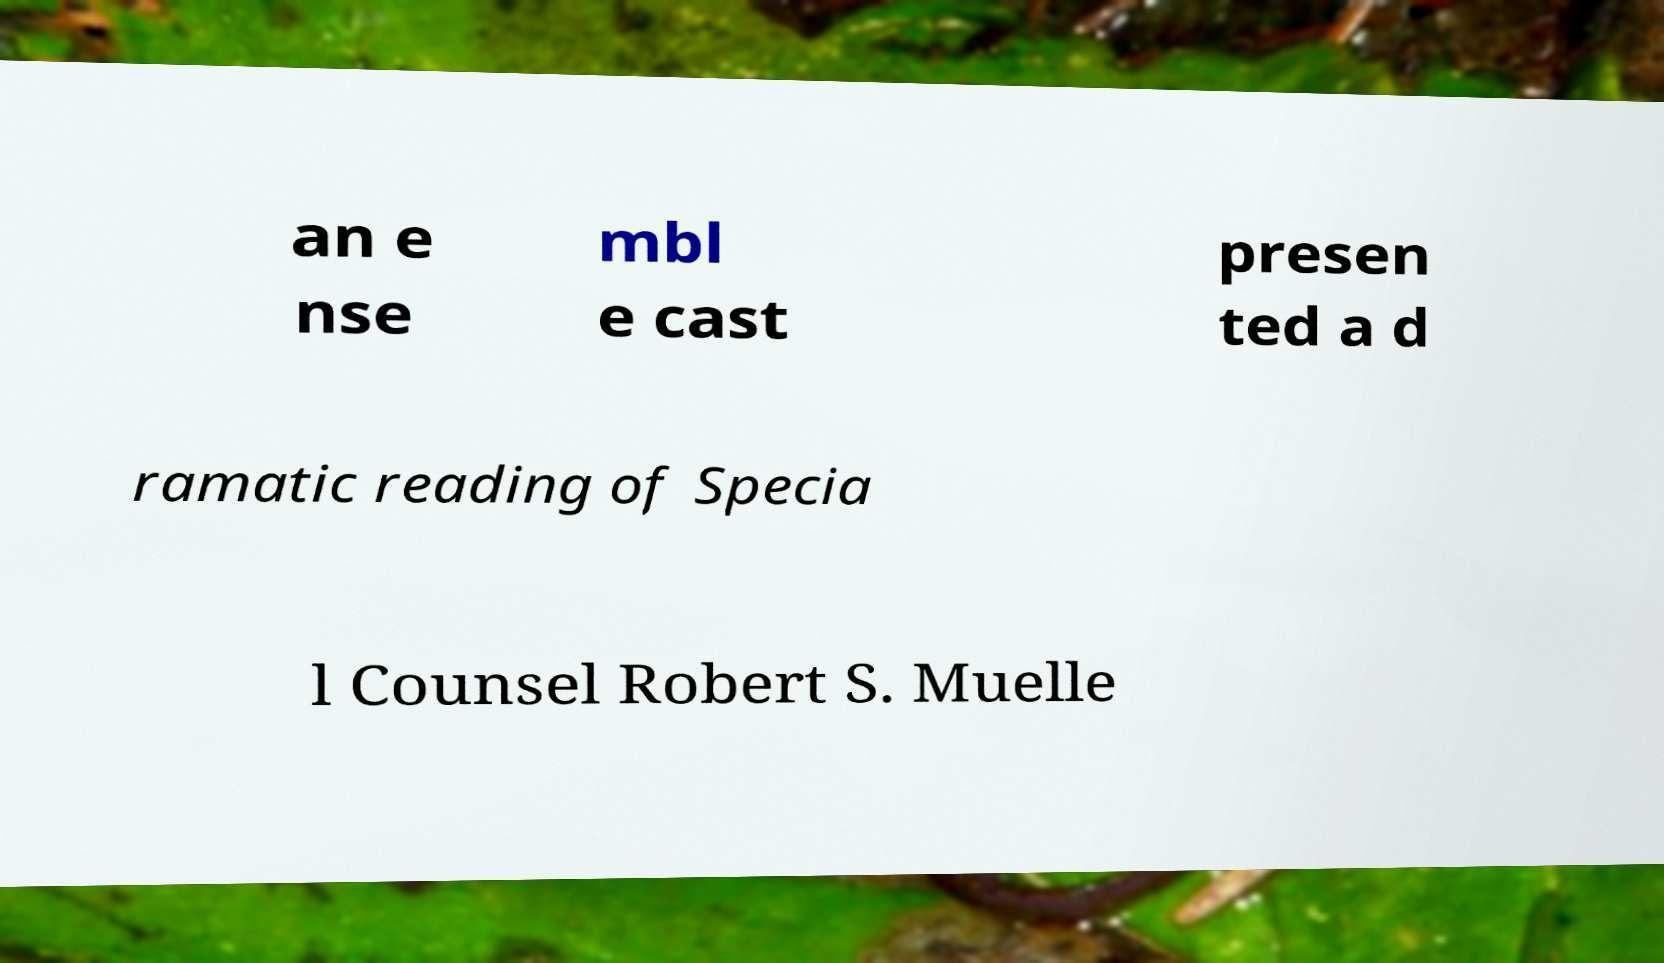What messages or text are displayed in this image? I need them in a readable, typed format. an e nse mbl e cast presen ted a d ramatic reading of Specia l Counsel Robert S. Muelle 